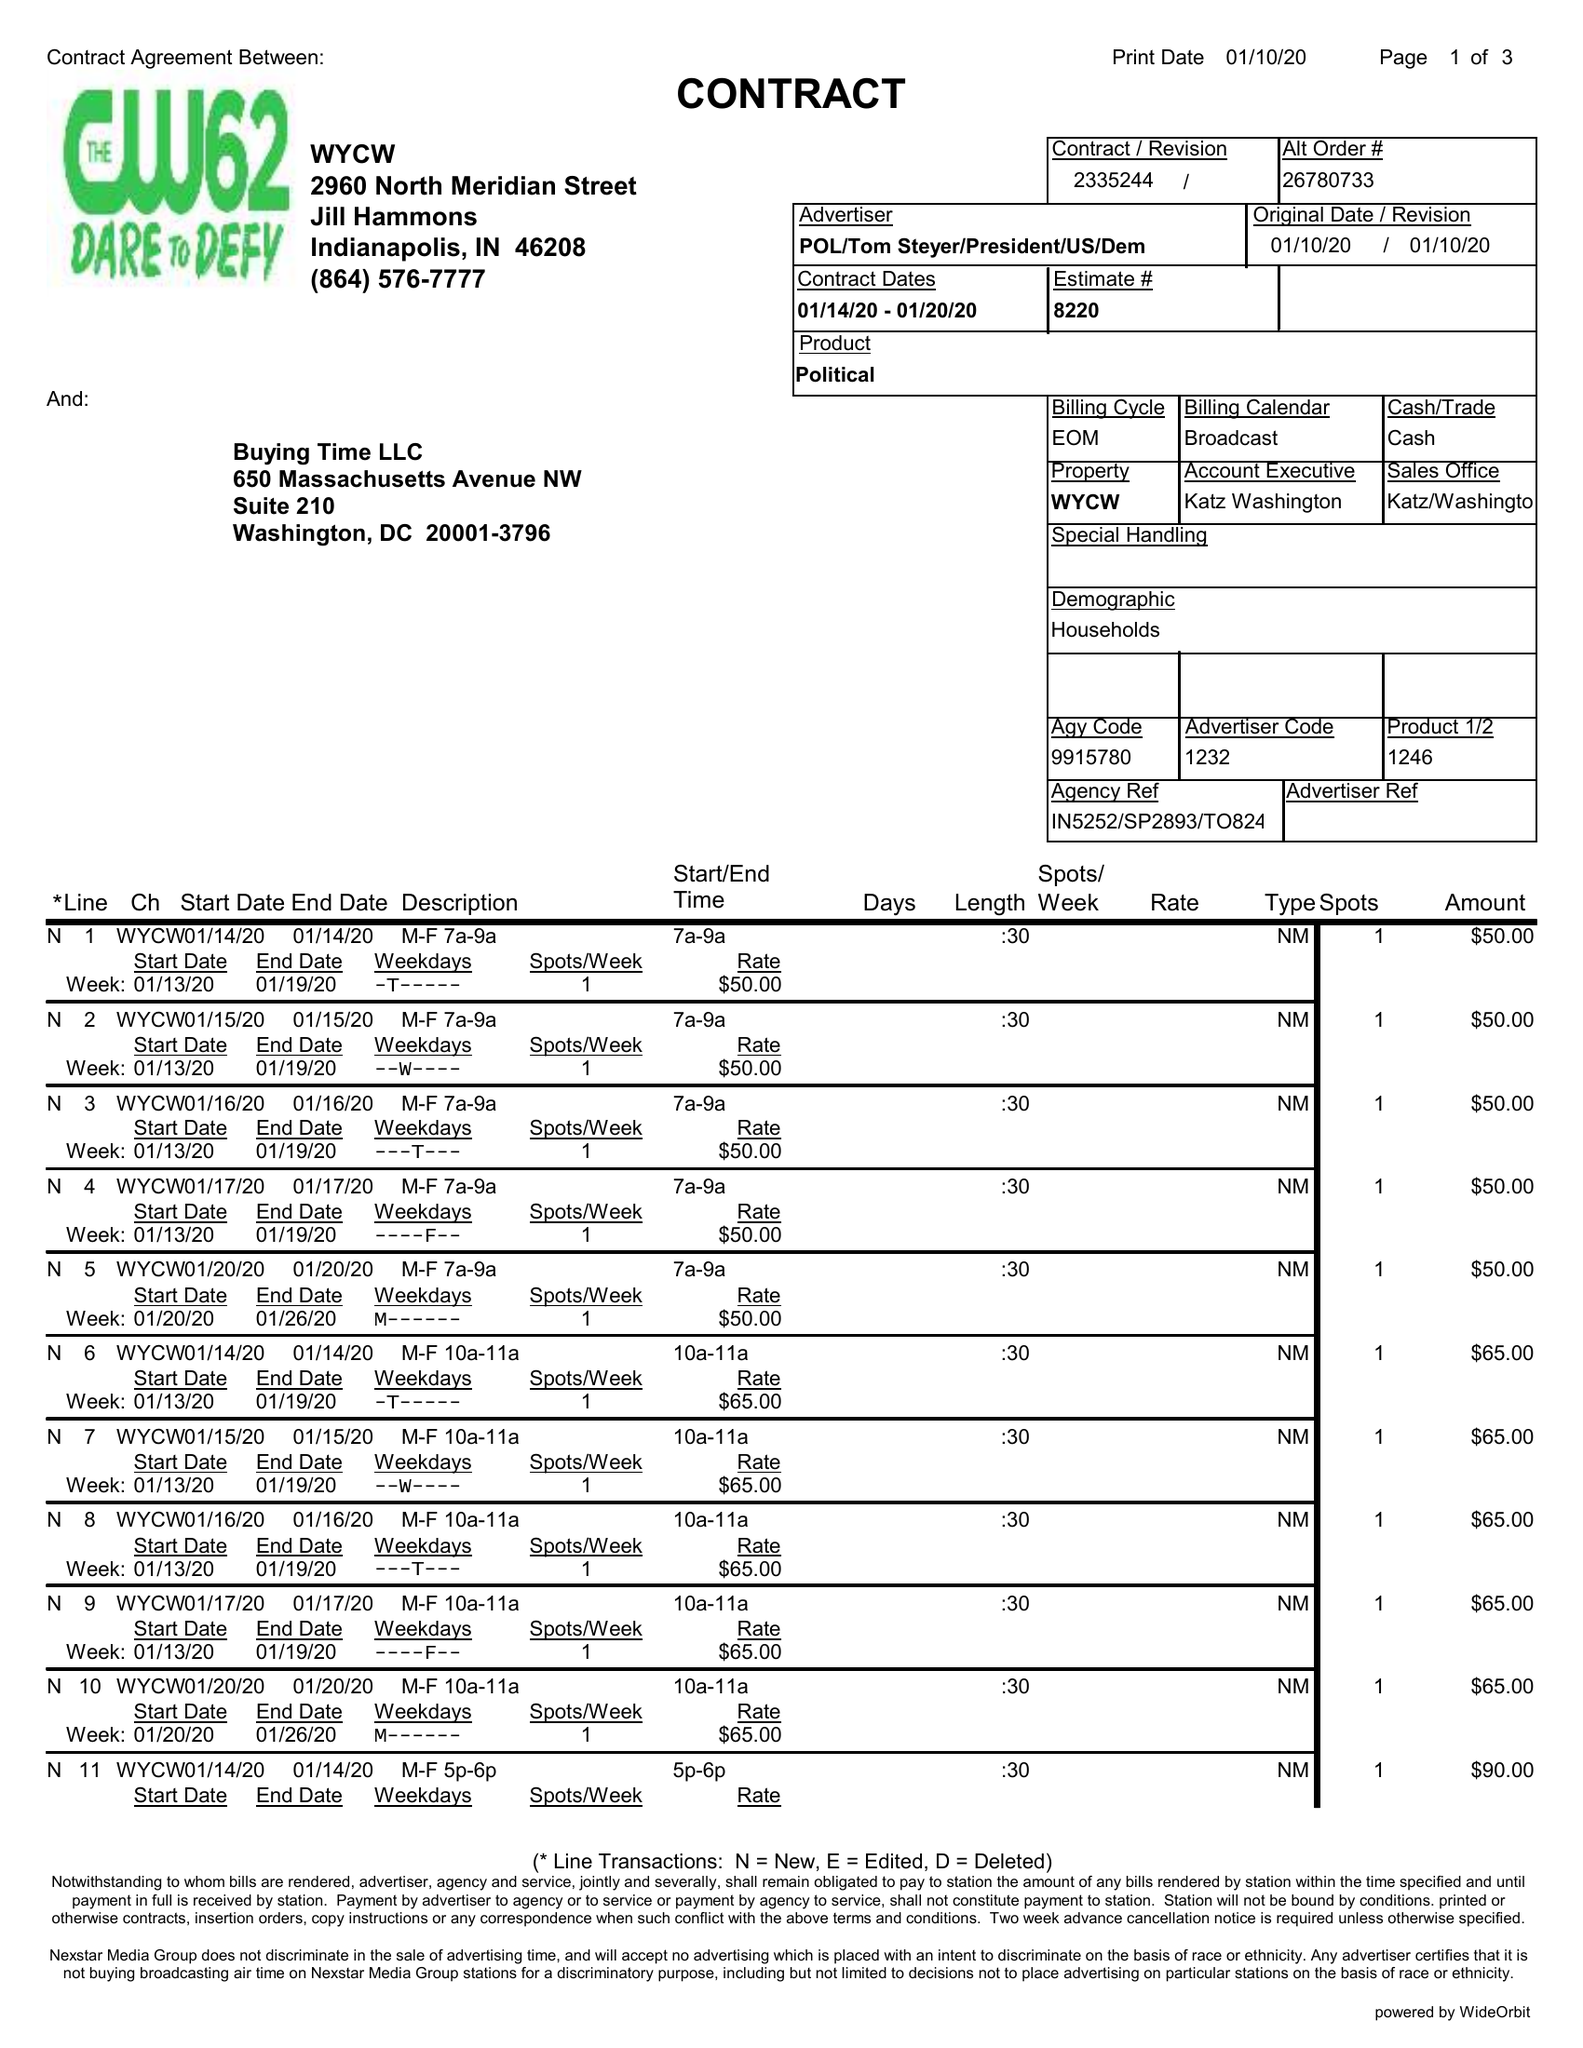What is the value for the contract_num?
Answer the question using a single word or phrase. 2335244 